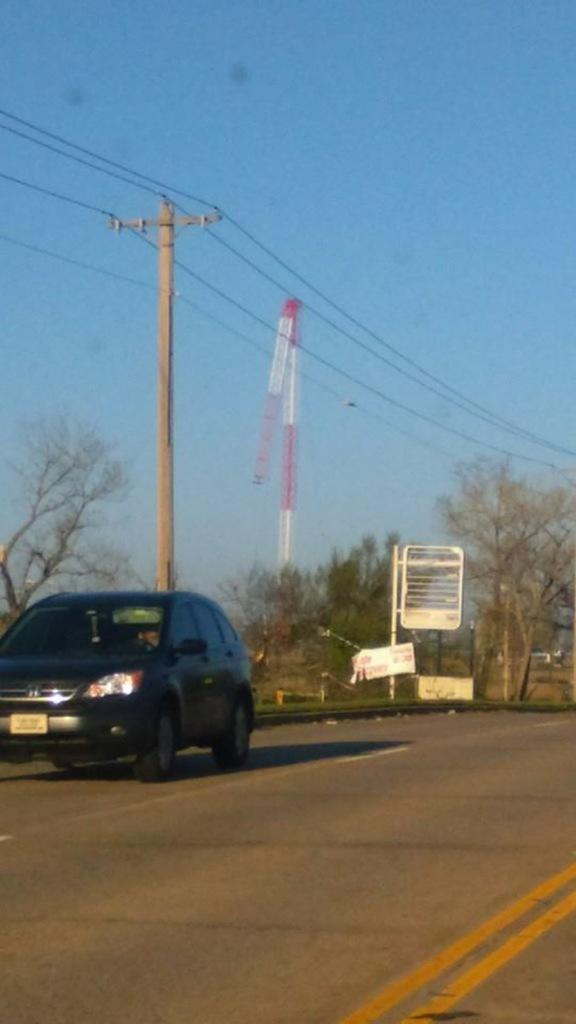What is at the bottom of the image? There is a road at the bottom of the image. What is on the road? There is a car on the road. What can be seen in the background of the image? Poles, trees, boards, wires, and the sky are visible in the background of the image. What type of marble is being used to pave the road in the image? There is no marble visible in the image; the road is not made of marble. 